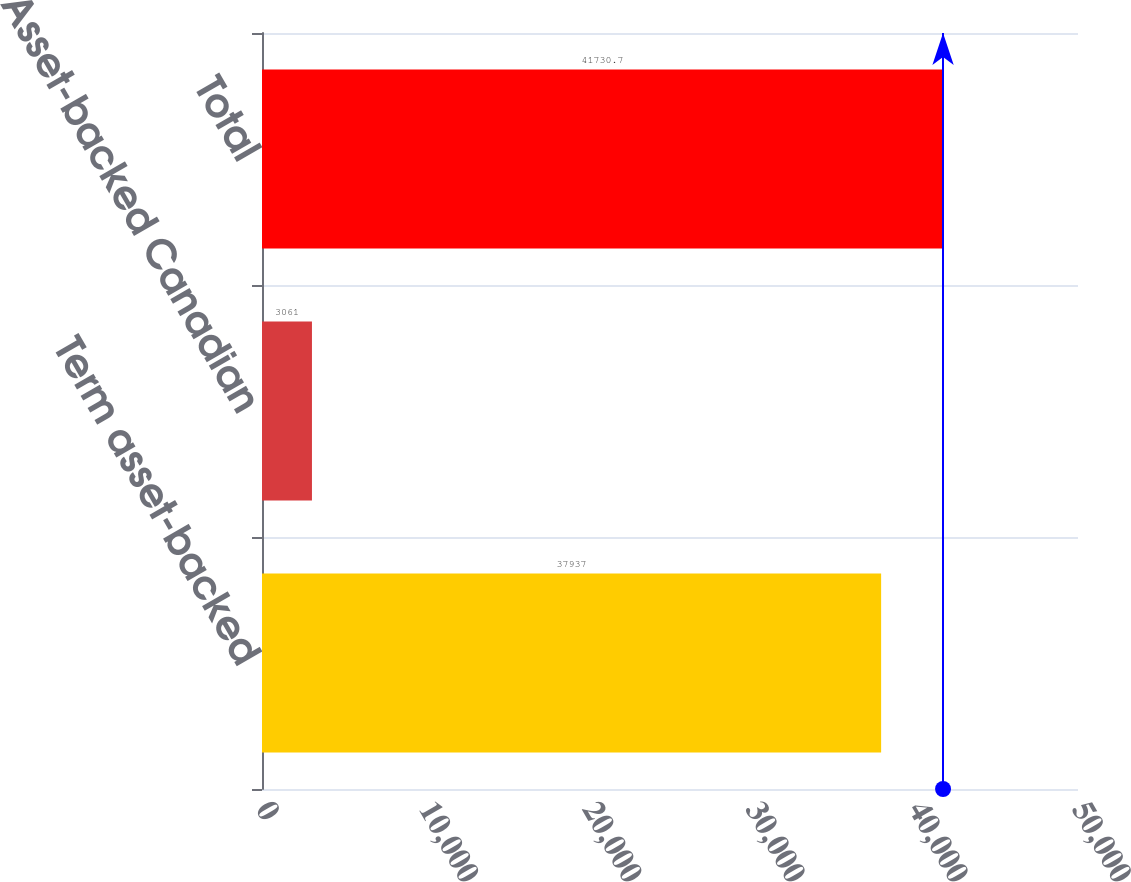Convert chart to OTSL. <chart><loc_0><loc_0><loc_500><loc_500><bar_chart><fcel>Term asset-backed<fcel>Asset-backed Canadian<fcel>Total<nl><fcel>37937<fcel>3061<fcel>41730.7<nl></chart> 